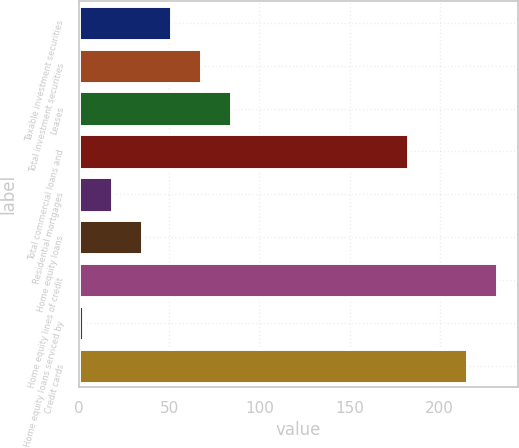Convert chart to OTSL. <chart><loc_0><loc_0><loc_500><loc_500><bar_chart><fcel>Taxable investment securities<fcel>Total investment securities<fcel>Leases<fcel>Total commercial loans and<fcel>Residential mortgages<fcel>Home equity loans<fcel>Home equity lines of credit<fcel>Home equity loans serviced by<fcel>Credit cards<nl><fcel>51.2<fcel>67.6<fcel>84<fcel>182.4<fcel>18.4<fcel>34.8<fcel>231.6<fcel>2<fcel>215.2<nl></chart> 